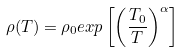Convert formula to latex. <formula><loc_0><loc_0><loc_500><loc_500>\rho ( T ) = \rho _ { 0 } e x p \left [ \left ( \frac { T _ { 0 } } { T } \right ) ^ { \alpha } \right ]</formula> 